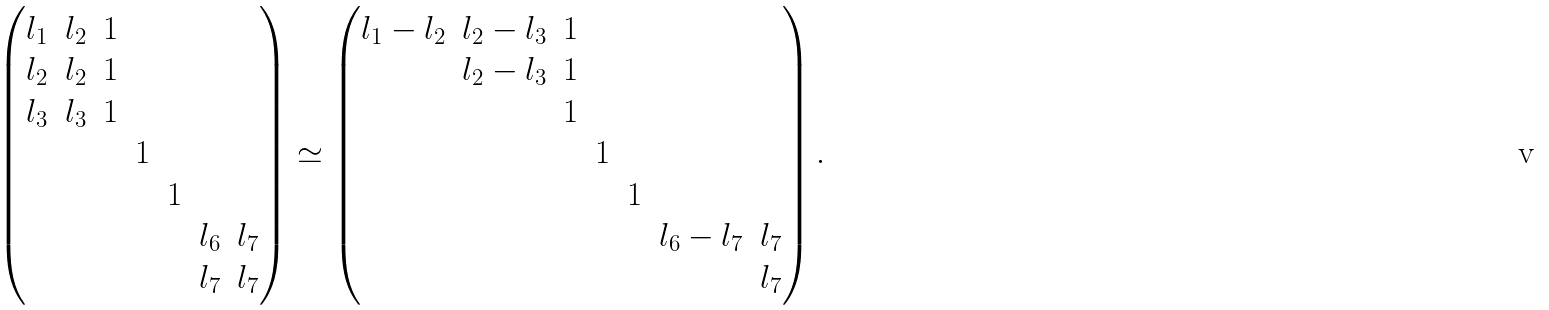Convert formula to latex. <formula><loc_0><loc_0><loc_500><loc_500>\begin{pmatrix} l _ { 1 } & l _ { 2 } & 1 & & & & \\ l _ { 2 } & l _ { 2 } & 1 & & & & \\ l _ { 3 } & l _ { 3 } & 1 & & & & \\ & & & 1 & & & \\ & & & & 1 & & \\ & & & & & l _ { 6 } & l _ { 7 } \\ & & & & & l _ { 7 } & l _ { 7 } \end{pmatrix} \simeq \begin{pmatrix} l _ { 1 } - l _ { 2 } & l _ { 2 } - l _ { 3 } & 1 & & & & \\ & l _ { 2 } - l _ { 3 } & 1 & & & & \\ & & 1 & & & & \\ & & & 1 & & & \\ & & & & 1 & & \\ & & & & & l _ { 6 } - l _ { 7 } & l _ { 7 } \\ & & & & & & l _ { 7 } \end{pmatrix} .</formula> 